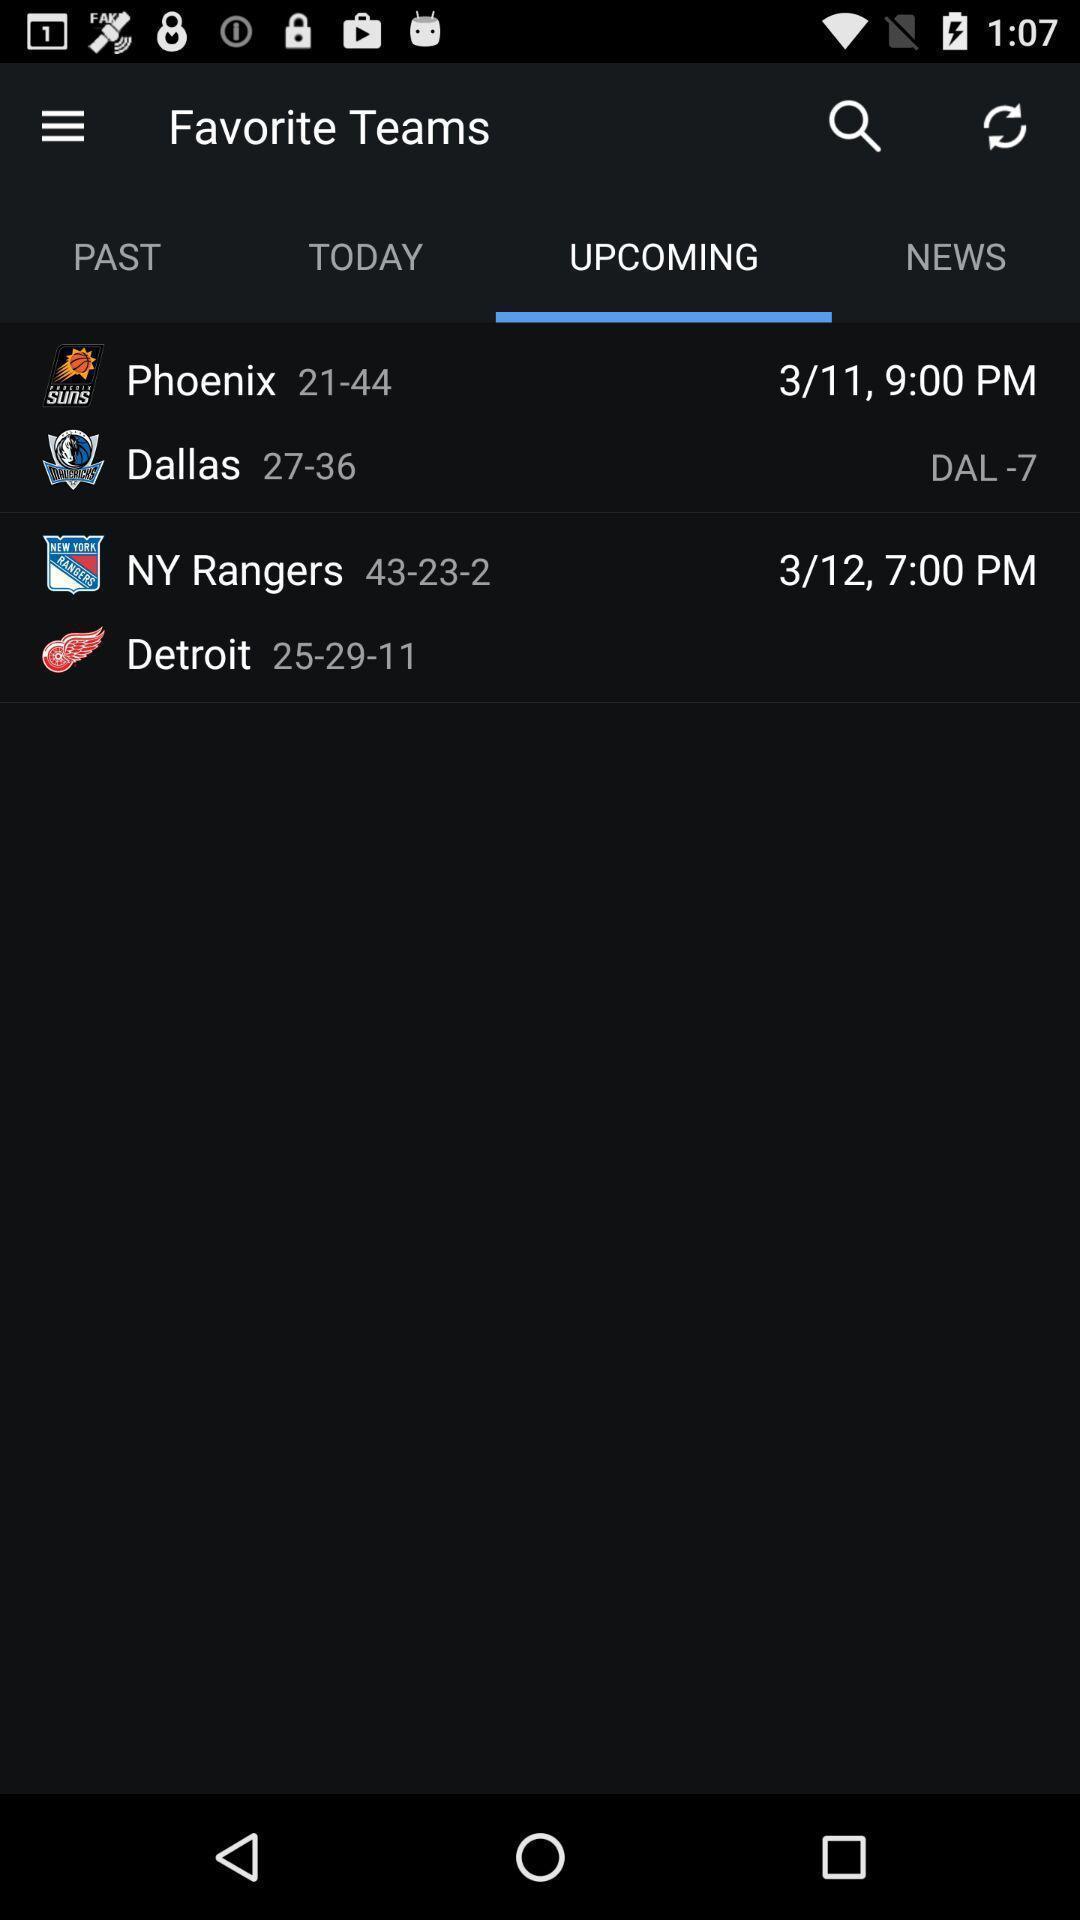What is the overall content of this screenshot? Page showing upcoming teams stats on app. 